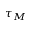Convert formula to latex. <formula><loc_0><loc_0><loc_500><loc_500>\tau _ { M }</formula> 